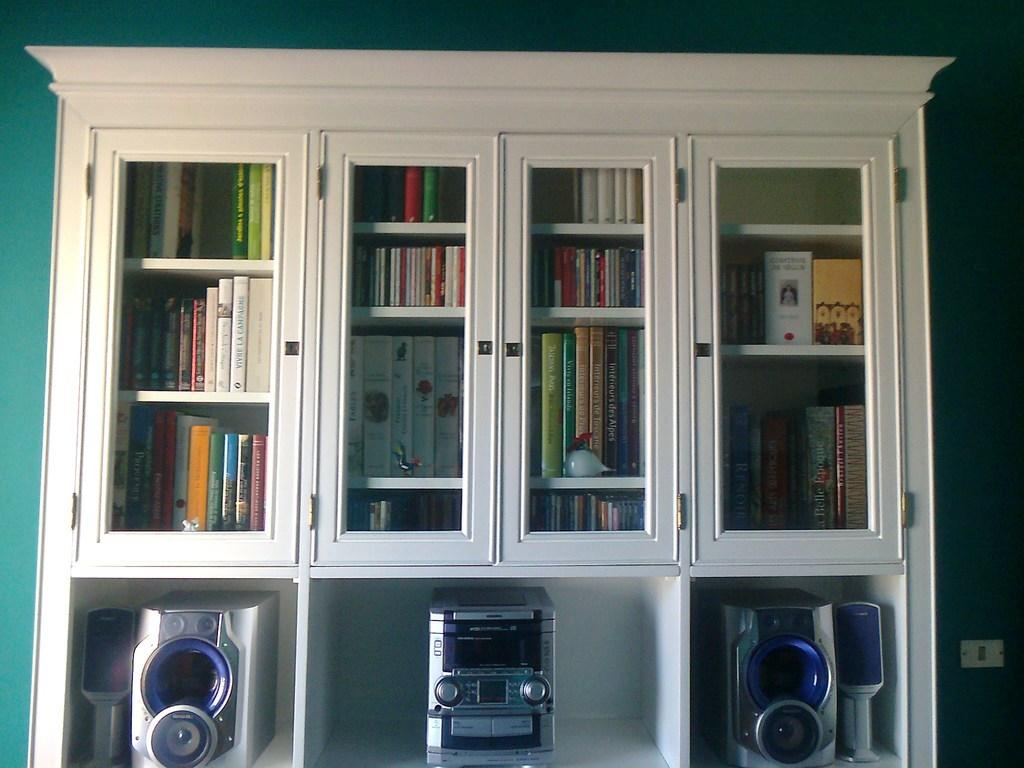<image>
Relay a brief, clear account of the picture shown. A bookcase has a stereo in it and several books including Vivre La Campagne. 